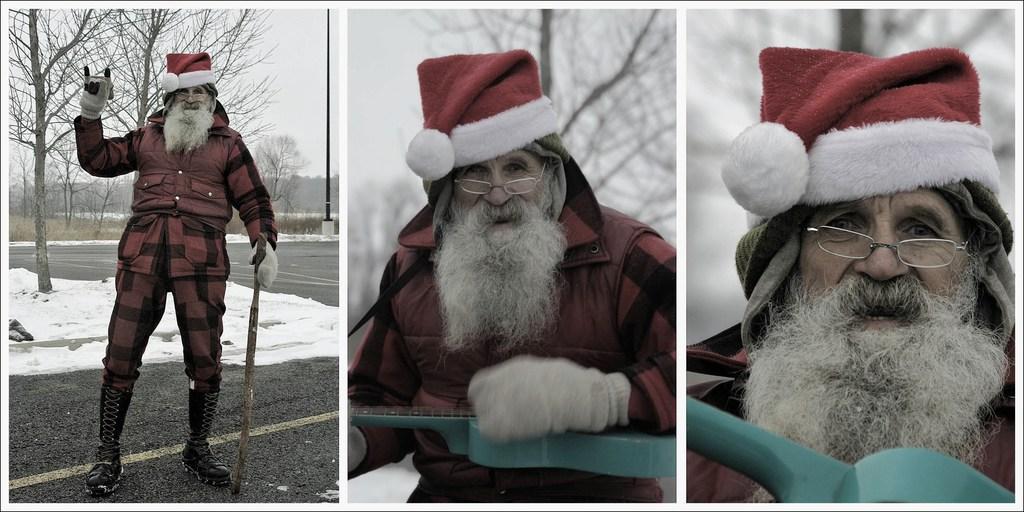Describe this image in one or two sentences. The image is collage of three pictures. In this picture we can see an old man. On the left image there is a person standing. In the background there are trees, snow, road, grass and sky. In the middle there is a person holding guitar. The background is blurred. On the right the person is holding an object. The background is blurred. 